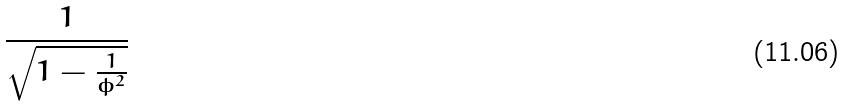Convert formula to latex. <formula><loc_0><loc_0><loc_500><loc_500>\frac { 1 } { \sqrt { 1 - \frac { 1 } { \phi ^ { 2 } } } }</formula> 